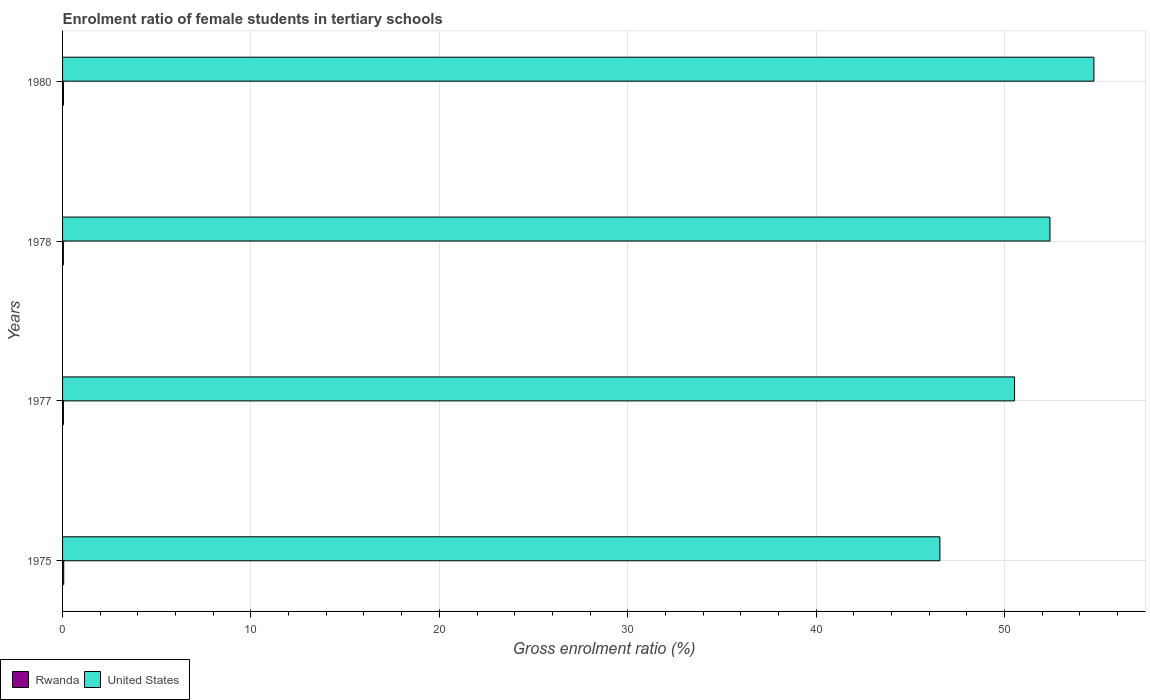Are the number of bars per tick equal to the number of legend labels?
Provide a short and direct response. Yes. How many bars are there on the 1st tick from the bottom?
Your response must be concise. 2. What is the label of the 4th group of bars from the top?
Provide a short and direct response. 1975. What is the enrolment ratio of female students in tertiary schools in United States in 1980?
Provide a short and direct response. 54.75. Across all years, what is the maximum enrolment ratio of female students in tertiary schools in United States?
Offer a very short reply. 54.75. Across all years, what is the minimum enrolment ratio of female students in tertiary schools in United States?
Keep it short and to the point. 46.57. In which year was the enrolment ratio of female students in tertiary schools in Rwanda minimum?
Your response must be concise. 1978. What is the total enrolment ratio of female students in tertiary schools in Rwanda in the graph?
Keep it short and to the point. 0.2. What is the difference between the enrolment ratio of female students in tertiary schools in Rwanda in 1975 and that in 1978?
Make the answer very short. 0.02. What is the difference between the enrolment ratio of female students in tertiary schools in United States in 1978 and the enrolment ratio of female students in tertiary schools in Rwanda in 1977?
Provide a succinct answer. 52.37. What is the average enrolment ratio of female students in tertiary schools in United States per year?
Offer a terse response. 51.07. In the year 1977, what is the difference between the enrolment ratio of female students in tertiary schools in Rwanda and enrolment ratio of female students in tertiary schools in United States?
Keep it short and to the point. -50.49. In how many years, is the enrolment ratio of female students in tertiary schools in Rwanda greater than 10 %?
Offer a very short reply. 0. What is the ratio of the enrolment ratio of female students in tertiary schools in Rwanda in 1975 to that in 1978?
Provide a succinct answer. 1.38. Is the enrolment ratio of female students in tertiary schools in Rwanda in 1975 less than that in 1980?
Offer a terse response. No. Is the difference between the enrolment ratio of female students in tertiary schools in Rwanda in 1975 and 1977 greater than the difference between the enrolment ratio of female students in tertiary schools in United States in 1975 and 1977?
Give a very brief answer. Yes. What is the difference between the highest and the second highest enrolment ratio of female students in tertiary schools in Rwanda?
Offer a terse response. 0.01. What is the difference between the highest and the lowest enrolment ratio of female students in tertiary schools in Rwanda?
Keep it short and to the point. 0.02. In how many years, is the enrolment ratio of female students in tertiary schools in United States greater than the average enrolment ratio of female students in tertiary schools in United States taken over all years?
Your answer should be very brief. 2. What does the 2nd bar from the top in 1977 represents?
Provide a succinct answer. Rwanda. How many years are there in the graph?
Your answer should be compact. 4. What is the difference between two consecutive major ticks on the X-axis?
Offer a very short reply. 10. Where does the legend appear in the graph?
Your answer should be compact. Bottom left. How are the legend labels stacked?
Ensure brevity in your answer.  Horizontal. What is the title of the graph?
Your answer should be very brief. Enrolment ratio of female students in tertiary schools. Does "Other small states" appear as one of the legend labels in the graph?
Provide a short and direct response. No. What is the Gross enrolment ratio (%) of Rwanda in 1975?
Your response must be concise. 0.06. What is the Gross enrolment ratio (%) of United States in 1975?
Offer a terse response. 46.57. What is the Gross enrolment ratio (%) in Rwanda in 1977?
Your answer should be compact. 0.04. What is the Gross enrolment ratio (%) of United States in 1977?
Give a very brief answer. 50.53. What is the Gross enrolment ratio (%) of Rwanda in 1978?
Give a very brief answer. 0.04. What is the Gross enrolment ratio (%) of United States in 1978?
Offer a terse response. 52.41. What is the Gross enrolment ratio (%) in Rwanda in 1980?
Ensure brevity in your answer.  0.05. What is the Gross enrolment ratio (%) in United States in 1980?
Ensure brevity in your answer.  54.75. Across all years, what is the maximum Gross enrolment ratio (%) of Rwanda?
Your response must be concise. 0.06. Across all years, what is the maximum Gross enrolment ratio (%) in United States?
Make the answer very short. 54.75. Across all years, what is the minimum Gross enrolment ratio (%) of Rwanda?
Offer a terse response. 0.04. Across all years, what is the minimum Gross enrolment ratio (%) of United States?
Keep it short and to the point. 46.57. What is the total Gross enrolment ratio (%) in Rwanda in the graph?
Make the answer very short. 0.2. What is the total Gross enrolment ratio (%) in United States in the graph?
Offer a terse response. 204.27. What is the difference between the Gross enrolment ratio (%) in Rwanda in 1975 and that in 1977?
Your answer should be very brief. 0.02. What is the difference between the Gross enrolment ratio (%) in United States in 1975 and that in 1977?
Give a very brief answer. -3.96. What is the difference between the Gross enrolment ratio (%) of Rwanda in 1975 and that in 1978?
Your answer should be very brief. 0.02. What is the difference between the Gross enrolment ratio (%) of United States in 1975 and that in 1978?
Give a very brief answer. -5.84. What is the difference between the Gross enrolment ratio (%) in Rwanda in 1975 and that in 1980?
Keep it short and to the point. 0.01. What is the difference between the Gross enrolment ratio (%) of United States in 1975 and that in 1980?
Keep it short and to the point. -8.18. What is the difference between the Gross enrolment ratio (%) in Rwanda in 1977 and that in 1978?
Your answer should be compact. 0. What is the difference between the Gross enrolment ratio (%) of United States in 1977 and that in 1978?
Make the answer very short. -1.88. What is the difference between the Gross enrolment ratio (%) in Rwanda in 1977 and that in 1980?
Offer a terse response. -0. What is the difference between the Gross enrolment ratio (%) in United States in 1977 and that in 1980?
Provide a succinct answer. -4.21. What is the difference between the Gross enrolment ratio (%) of Rwanda in 1978 and that in 1980?
Provide a short and direct response. -0.01. What is the difference between the Gross enrolment ratio (%) in United States in 1978 and that in 1980?
Provide a short and direct response. -2.33. What is the difference between the Gross enrolment ratio (%) of Rwanda in 1975 and the Gross enrolment ratio (%) of United States in 1977?
Give a very brief answer. -50.47. What is the difference between the Gross enrolment ratio (%) in Rwanda in 1975 and the Gross enrolment ratio (%) in United States in 1978?
Give a very brief answer. -52.35. What is the difference between the Gross enrolment ratio (%) of Rwanda in 1975 and the Gross enrolment ratio (%) of United States in 1980?
Offer a terse response. -54.69. What is the difference between the Gross enrolment ratio (%) in Rwanda in 1977 and the Gross enrolment ratio (%) in United States in 1978?
Provide a succinct answer. -52.37. What is the difference between the Gross enrolment ratio (%) of Rwanda in 1977 and the Gross enrolment ratio (%) of United States in 1980?
Your answer should be very brief. -54.7. What is the difference between the Gross enrolment ratio (%) in Rwanda in 1978 and the Gross enrolment ratio (%) in United States in 1980?
Your answer should be compact. -54.7. What is the average Gross enrolment ratio (%) of Rwanda per year?
Keep it short and to the point. 0.05. What is the average Gross enrolment ratio (%) in United States per year?
Offer a terse response. 51.07. In the year 1975, what is the difference between the Gross enrolment ratio (%) of Rwanda and Gross enrolment ratio (%) of United States?
Make the answer very short. -46.51. In the year 1977, what is the difference between the Gross enrolment ratio (%) of Rwanda and Gross enrolment ratio (%) of United States?
Your answer should be compact. -50.49. In the year 1978, what is the difference between the Gross enrolment ratio (%) in Rwanda and Gross enrolment ratio (%) in United States?
Provide a short and direct response. -52.37. In the year 1980, what is the difference between the Gross enrolment ratio (%) in Rwanda and Gross enrolment ratio (%) in United States?
Your answer should be compact. -54.7. What is the ratio of the Gross enrolment ratio (%) of Rwanda in 1975 to that in 1977?
Your answer should be very brief. 1.37. What is the ratio of the Gross enrolment ratio (%) in United States in 1975 to that in 1977?
Your answer should be very brief. 0.92. What is the ratio of the Gross enrolment ratio (%) of Rwanda in 1975 to that in 1978?
Provide a succinct answer. 1.38. What is the ratio of the Gross enrolment ratio (%) of United States in 1975 to that in 1978?
Keep it short and to the point. 0.89. What is the ratio of the Gross enrolment ratio (%) in Rwanda in 1975 to that in 1980?
Provide a succinct answer. 1.24. What is the ratio of the Gross enrolment ratio (%) of United States in 1975 to that in 1980?
Your answer should be compact. 0.85. What is the ratio of the Gross enrolment ratio (%) in Rwanda in 1977 to that in 1978?
Provide a succinct answer. 1.01. What is the ratio of the Gross enrolment ratio (%) in United States in 1977 to that in 1978?
Give a very brief answer. 0.96. What is the ratio of the Gross enrolment ratio (%) of Rwanda in 1977 to that in 1980?
Offer a terse response. 0.91. What is the ratio of the Gross enrolment ratio (%) of Rwanda in 1978 to that in 1980?
Offer a terse response. 0.9. What is the ratio of the Gross enrolment ratio (%) of United States in 1978 to that in 1980?
Keep it short and to the point. 0.96. What is the difference between the highest and the second highest Gross enrolment ratio (%) of Rwanda?
Make the answer very short. 0.01. What is the difference between the highest and the second highest Gross enrolment ratio (%) in United States?
Keep it short and to the point. 2.33. What is the difference between the highest and the lowest Gross enrolment ratio (%) in Rwanda?
Provide a succinct answer. 0.02. What is the difference between the highest and the lowest Gross enrolment ratio (%) in United States?
Your response must be concise. 8.18. 